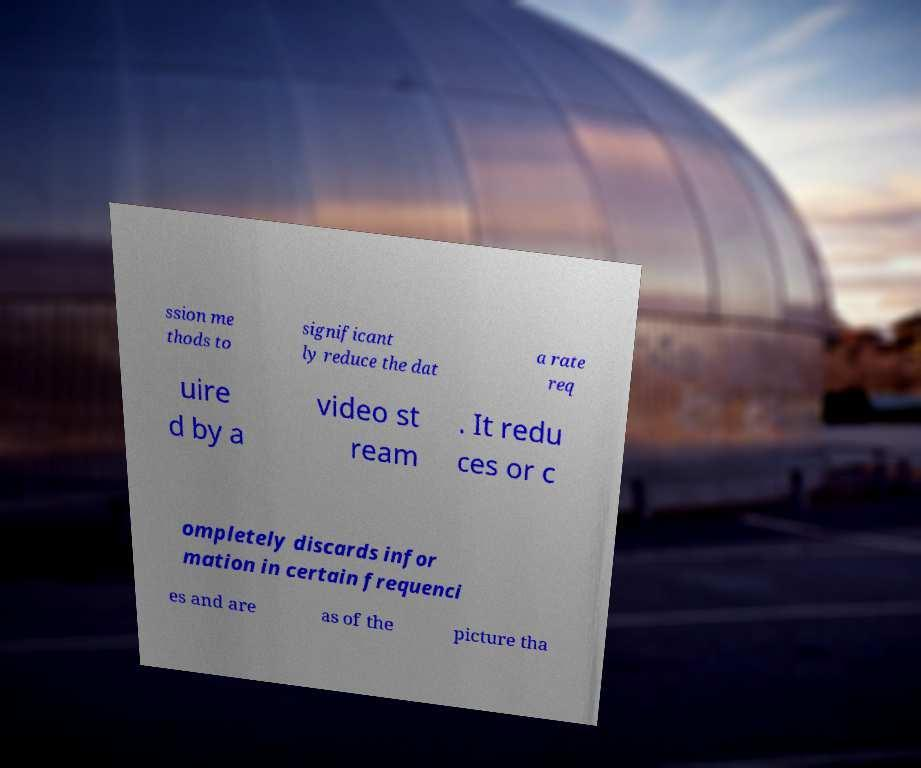I need the written content from this picture converted into text. Can you do that? ssion me thods to significant ly reduce the dat a rate req uire d by a video st ream . It redu ces or c ompletely discards infor mation in certain frequenci es and are as of the picture tha 